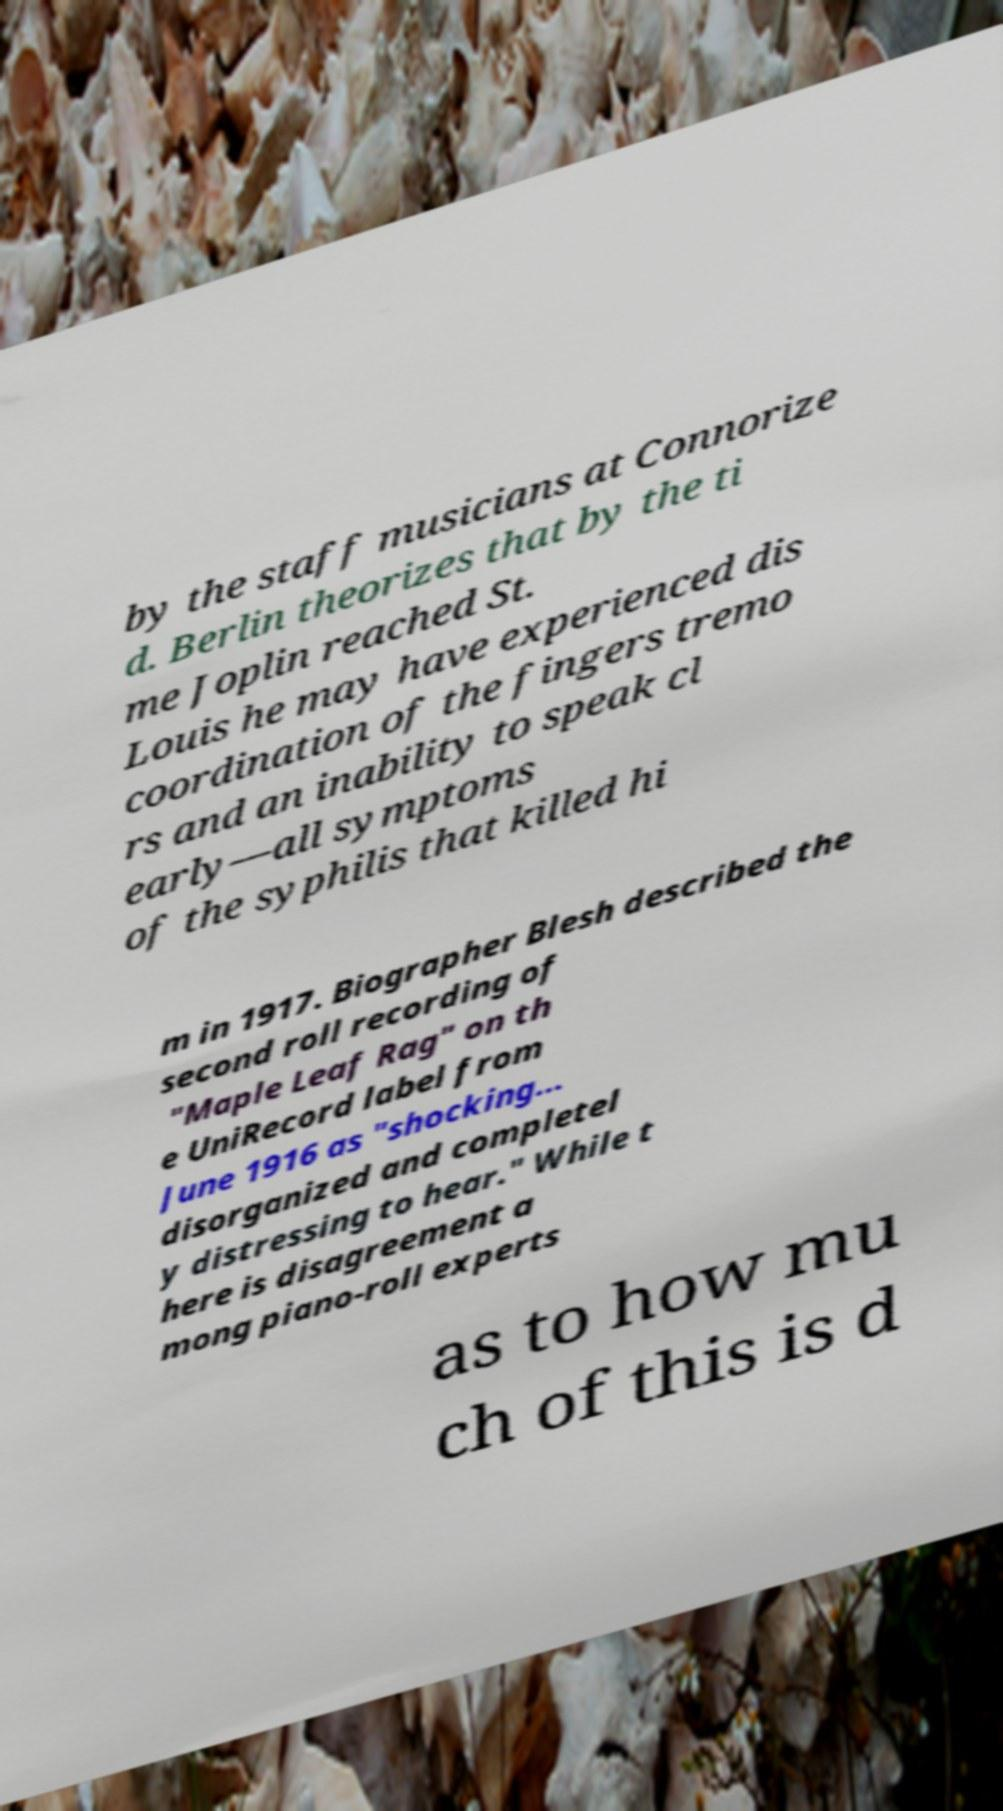Please identify and transcribe the text found in this image. by the staff musicians at Connorize d. Berlin theorizes that by the ti me Joplin reached St. Louis he may have experienced dis coordination of the fingers tremo rs and an inability to speak cl early—all symptoms of the syphilis that killed hi m in 1917. Biographer Blesh described the second roll recording of "Maple Leaf Rag" on th e UniRecord label from June 1916 as "shocking... disorganized and completel y distressing to hear." While t here is disagreement a mong piano-roll experts as to how mu ch of this is d 